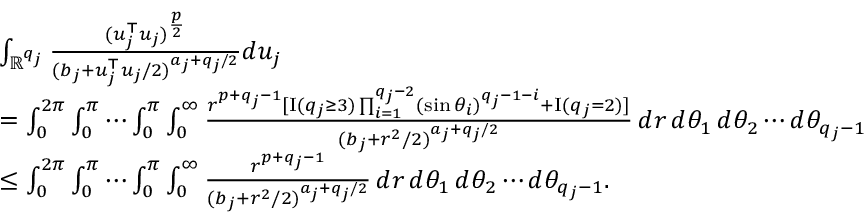Convert formula to latex. <formula><loc_0><loc_0><loc_500><loc_500>\begin{array} { r l } & { \int _ { \mathbb { R } ^ { q _ { j } } } \frac { ( u _ { j } ^ { \top } u _ { j } ) ^ { \frac { p } { 2 } } } { ( b _ { j } + u _ { j } ^ { \top } u _ { j } / 2 ) ^ { a _ { j } + q _ { j } / 2 } } d u _ { j } } \\ & { = \int _ { 0 } ^ { 2 \pi } \int _ { 0 } ^ { \pi } \cdots \int _ { 0 } ^ { \pi } \int _ { 0 } ^ { \infty } \frac { r ^ { p + q _ { j } - 1 } [ { I } ( q _ { j } \geq 3 ) \prod _ { i = 1 } ^ { q _ { j } - 2 } ( \sin \theta _ { i } ) ^ { q _ { j } - 1 - i } + { I } ( q _ { j } = 2 ) ] } { ( b _ { j } + r ^ { 2 } / 2 ) ^ { a _ { j } + q _ { j } / 2 } } \, d r \, d \theta _ { 1 } \, d \theta _ { 2 } \cdots d \theta _ { q _ { j } - 1 } } \\ & { \leq \int _ { 0 } ^ { 2 \pi } \int _ { 0 } ^ { \pi } \cdots \int _ { 0 } ^ { \pi } \int _ { 0 } ^ { \infty } \frac { r ^ { p + q _ { j } - 1 } } { ( b _ { j } + r ^ { 2 } / 2 ) ^ { a _ { j } + q _ { j } / 2 } } \, d r \, d \theta _ { 1 } \, d \theta _ { 2 } \cdots d \theta _ { q _ { j } - 1 } . } \end{array}</formula> 